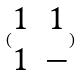Convert formula to latex. <formula><loc_0><loc_0><loc_500><loc_500>( \begin{matrix} 1 & 1 \\ 1 & - \end{matrix} )</formula> 